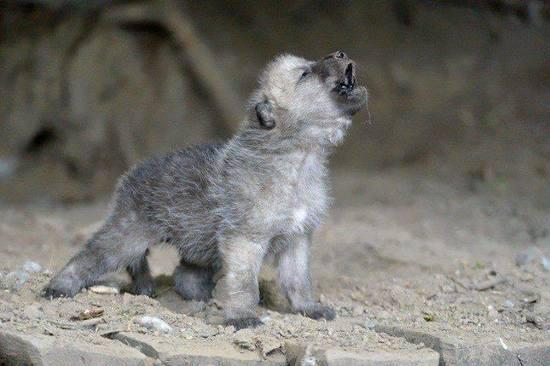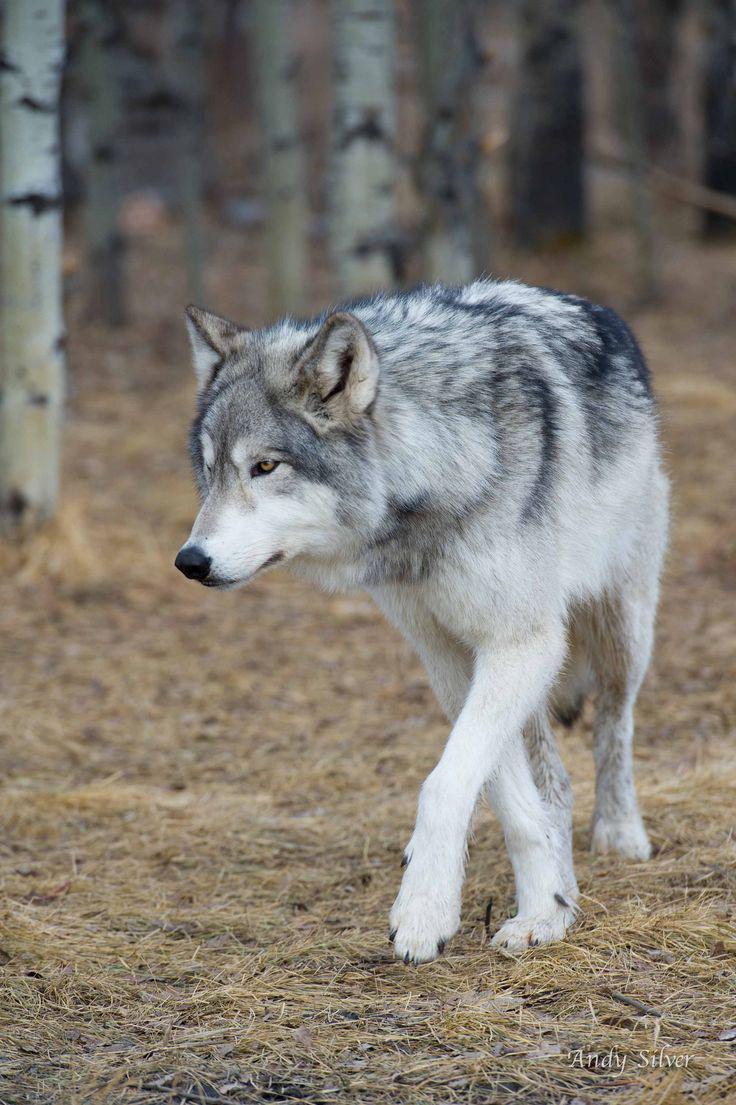The first image is the image on the left, the second image is the image on the right. Analyze the images presented: Is the assertion "One image shows a wolf in a snowy scene." valid? Answer yes or no. No. The first image is the image on the left, the second image is the image on the right. Examine the images to the left and right. Is the description "the animal in the image on the right is facing right" accurate? Answer yes or no. No. The first image is the image on the left, the second image is the image on the right. For the images displayed, is the sentence "The animal in the image on the right is looking toward the camera" factually correct? Answer yes or no. No. The first image is the image on the left, the second image is the image on the right. Evaluate the accuracy of this statement regarding the images: "An image shows a standing wolf facing the camera.". Is it true? Answer yes or no. No. The first image is the image on the left, the second image is the image on the right. Given the left and right images, does the statement "There is one young wolf in one of the images." hold true? Answer yes or no. Yes. 